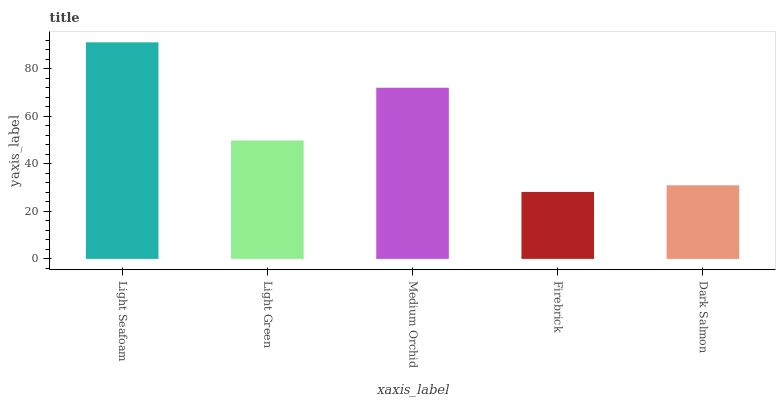Is Firebrick the minimum?
Answer yes or no. Yes. Is Light Seafoam the maximum?
Answer yes or no. Yes. Is Light Green the minimum?
Answer yes or no. No. Is Light Green the maximum?
Answer yes or no. No. Is Light Seafoam greater than Light Green?
Answer yes or no. Yes. Is Light Green less than Light Seafoam?
Answer yes or no. Yes. Is Light Green greater than Light Seafoam?
Answer yes or no. No. Is Light Seafoam less than Light Green?
Answer yes or no. No. Is Light Green the high median?
Answer yes or no. Yes. Is Light Green the low median?
Answer yes or no. Yes. Is Dark Salmon the high median?
Answer yes or no. No. Is Light Seafoam the low median?
Answer yes or no. No. 